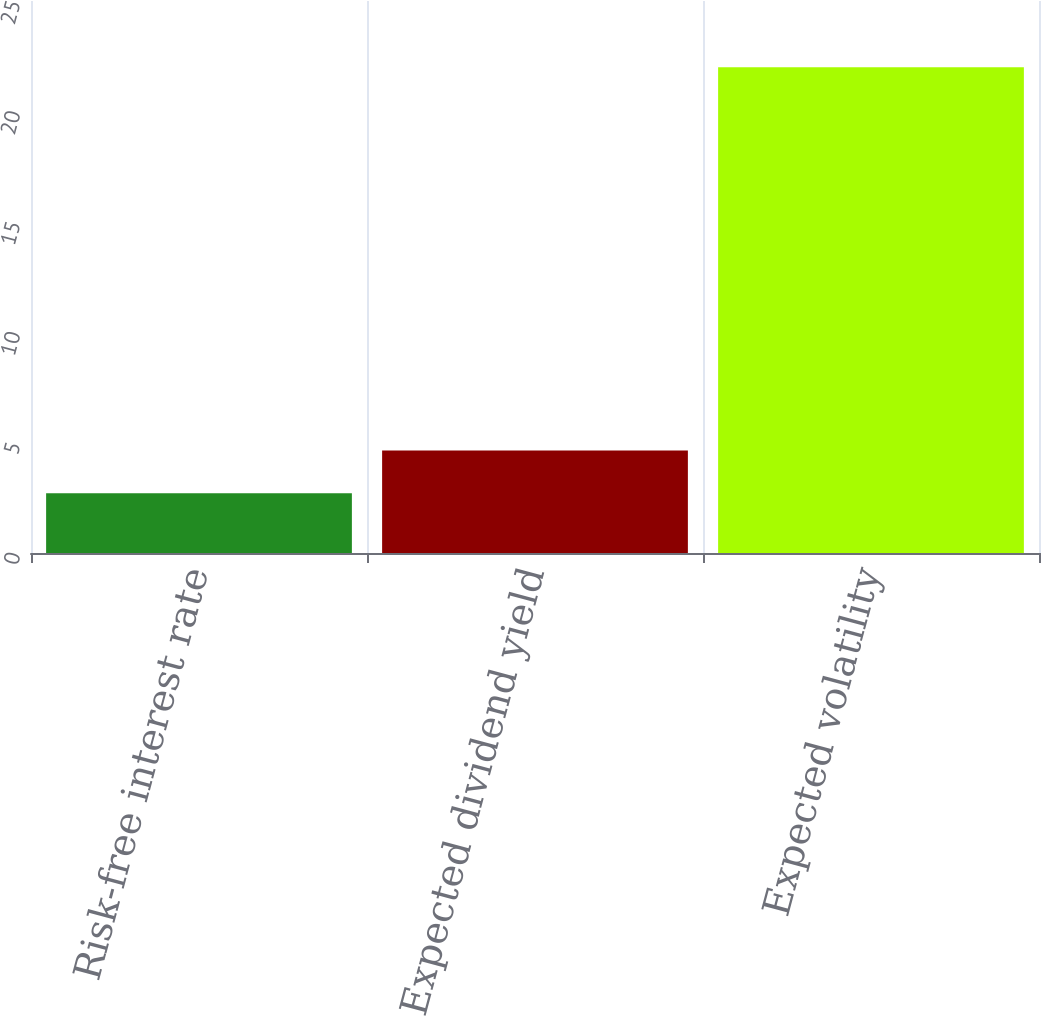Convert chart to OTSL. <chart><loc_0><loc_0><loc_500><loc_500><bar_chart><fcel>Risk-free interest rate<fcel>Expected dividend yield<fcel>Expected volatility<nl><fcel>2.71<fcel>4.64<fcel>22<nl></chart> 